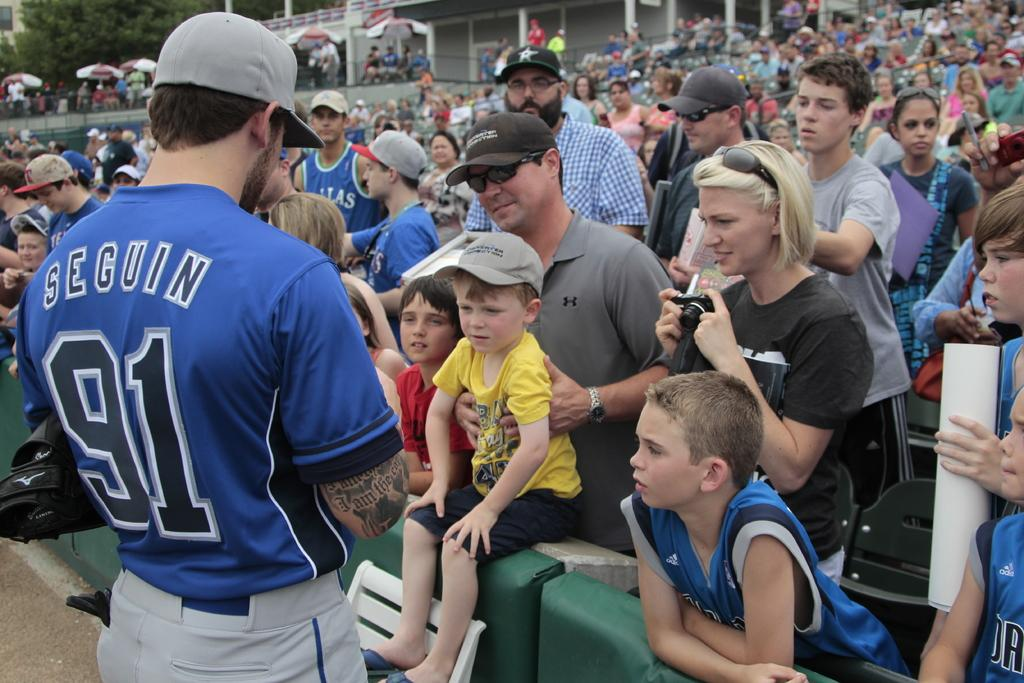<image>
Render a clear and concise summary of the photo. A family talks with a man wearing a jersey that has the name SEGUIN and the number 91 on it. 